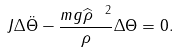Convert formula to latex. <formula><loc_0><loc_0><loc_500><loc_500>J \Delta \ddot { \Theta } - \frac { m g \widehat { \rho } ^ { \ 2 } } { \| \rho \| } \Delta \Theta = 0 .</formula> 